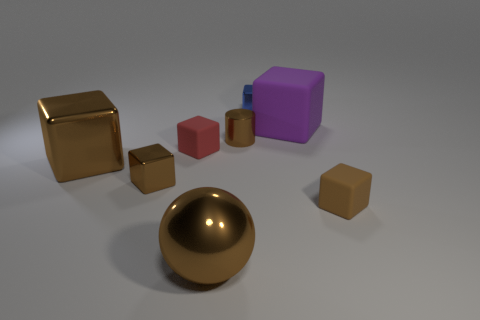Add 1 small brown rubber cubes. How many objects exist? 9 Subtract all small blue blocks. How many blocks are left? 5 Subtract all brown cubes. How many cubes are left? 3 Subtract all cubes. How many objects are left? 2 Subtract all yellow spheres. How many blue cubes are left? 1 Subtract all tiny brown things. Subtract all objects. How many objects are left? 2 Add 2 big purple rubber things. How many big purple rubber things are left? 3 Add 1 brown objects. How many brown objects exist? 6 Subtract 0 blue cylinders. How many objects are left? 8 Subtract 1 cylinders. How many cylinders are left? 0 